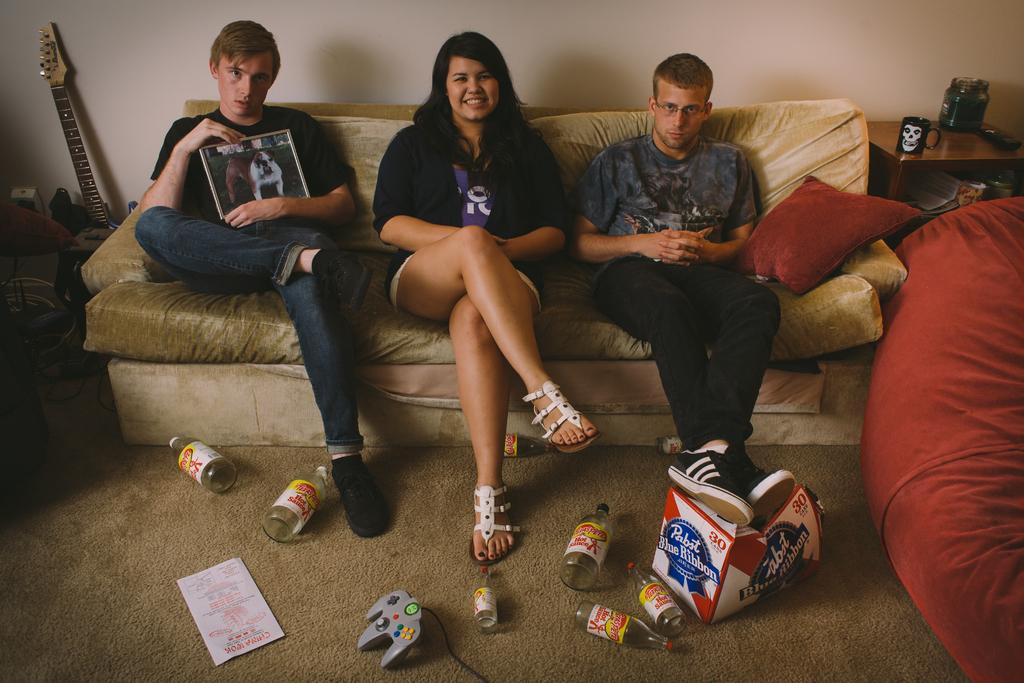Is that a case of 30?
Your answer should be compact. Yes. What brand of beer?
Give a very brief answer. Pabst blue ribbon. 